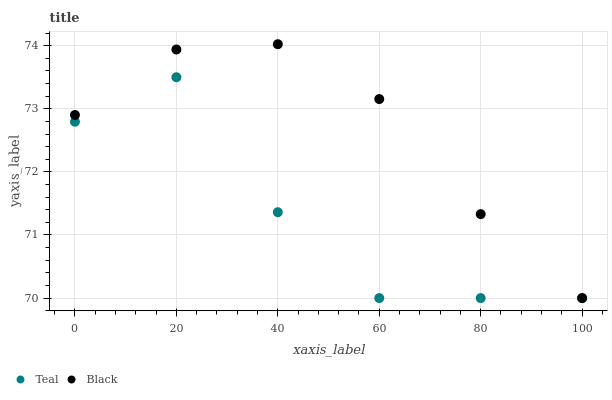Does Teal have the minimum area under the curve?
Answer yes or no. Yes. Does Black have the maximum area under the curve?
Answer yes or no. Yes. Does Teal have the maximum area under the curve?
Answer yes or no. No. Is Black the smoothest?
Answer yes or no. Yes. Is Teal the roughest?
Answer yes or no. Yes. Is Teal the smoothest?
Answer yes or no. No. Does Black have the lowest value?
Answer yes or no. Yes. Does Black have the highest value?
Answer yes or no. Yes. Does Teal have the highest value?
Answer yes or no. No. Does Teal intersect Black?
Answer yes or no. Yes. Is Teal less than Black?
Answer yes or no. No. Is Teal greater than Black?
Answer yes or no. No. 